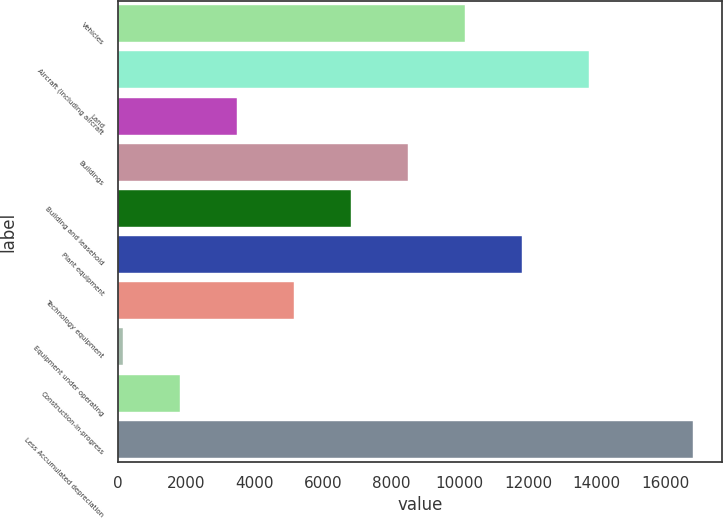Convert chart. <chart><loc_0><loc_0><loc_500><loc_500><bar_chart><fcel>Vehicles<fcel>Aircraft (including aircraft<fcel>Land<fcel>Buildings<fcel>Building and leasehold<fcel>Plant equipment<fcel>Technology equipment<fcel>Equipment under operating<fcel>Construction-in-progress<fcel>Less Accumulated depreciation<nl><fcel>10154.8<fcel>13777<fcel>3481.6<fcel>8486.5<fcel>6818.2<fcel>11823.1<fcel>5149.9<fcel>145<fcel>1813.3<fcel>16828<nl></chart> 